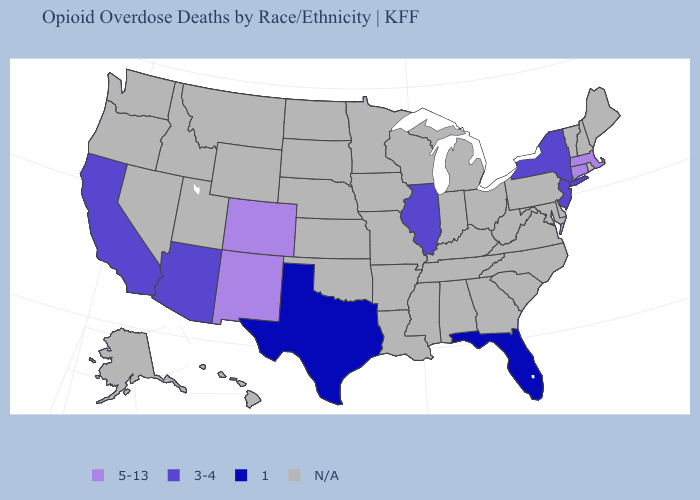What is the value of New Jersey?
Write a very short answer. 3-4. What is the lowest value in the Northeast?
Quick response, please. 3-4. Is the legend a continuous bar?
Quick response, please. No. Does New York have the lowest value in the Northeast?
Give a very brief answer. Yes. Among the states that border Oklahoma , does Texas have the lowest value?
Concise answer only. Yes. What is the value of New Jersey?
Concise answer only. 3-4. What is the lowest value in the South?
Concise answer only. 1. Name the states that have a value in the range N/A?
Quick response, please. Alabama, Alaska, Arkansas, Delaware, Georgia, Hawaii, Idaho, Indiana, Iowa, Kansas, Kentucky, Louisiana, Maine, Maryland, Michigan, Minnesota, Mississippi, Missouri, Montana, Nebraska, Nevada, New Hampshire, North Carolina, North Dakota, Ohio, Oklahoma, Oregon, Pennsylvania, Rhode Island, South Carolina, South Dakota, Tennessee, Utah, Vermont, Virginia, Washington, West Virginia, Wisconsin, Wyoming. What is the value of Indiana?
Keep it brief. N/A. Among the states that border Georgia , which have the lowest value?
Give a very brief answer. Florida. Name the states that have a value in the range 1?
Answer briefly. Florida, Texas. Name the states that have a value in the range 3-4?
Short answer required. Arizona, California, Illinois, New Jersey, New York. 